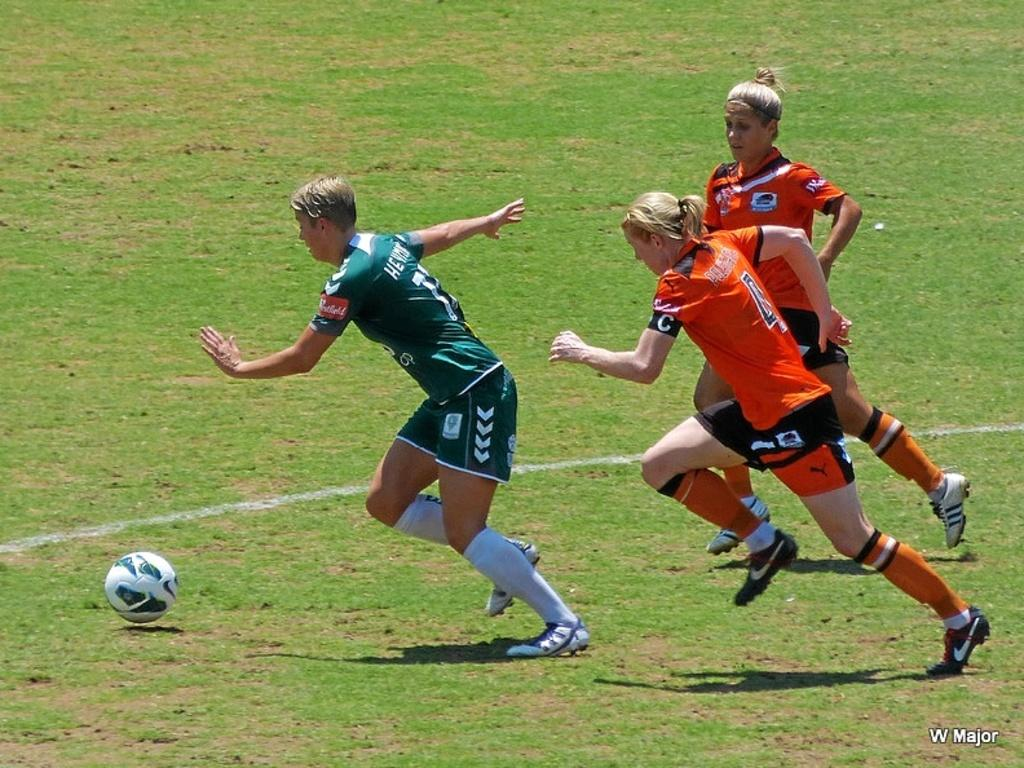What activity are the girls in the image engaged in? The girls are playing football in the image. Where are the girls located in the image? The girls are in the center of the image. What type of surface are the girls playing on? There is grass at the bottom of the image. What else can be seen in the image besides the girls playing football? There is some text to the right side of the image. How many chickens are there in the image? There are no chickens present in the image. What type of lamp is being used to measure the distance between the girls? There is no lamp or measuring device present in the image. 